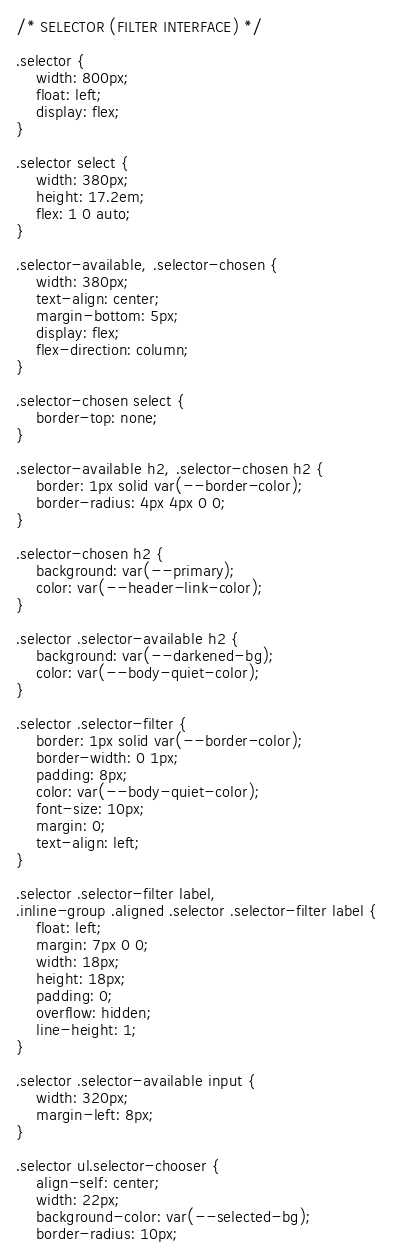Convert code to text. <code><loc_0><loc_0><loc_500><loc_500><_CSS_>/* SELECTOR (FILTER INTERFACE) */

.selector {
    width: 800px;
    float: left;
    display: flex;
}

.selector select {
    width: 380px;
    height: 17.2em;
    flex: 1 0 auto;
}

.selector-available, .selector-chosen {
    width: 380px;
    text-align: center;
    margin-bottom: 5px;
    display: flex;
    flex-direction: column;
}

.selector-chosen select {
    border-top: none;
}

.selector-available h2, .selector-chosen h2 {
    border: 1px solid var(--border-color);
    border-radius: 4px 4px 0 0;
}

.selector-chosen h2 {
    background: var(--primary);
    color: var(--header-link-color);
}

.selector .selector-available h2 {
    background: var(--darkened-bg);
    color: var(--body-quiet-color);
}

.selector .selector-filter {
    border: 1px solid var(--border-color);
    border-width: 0 1px;
    padding: 8px;
    color: var(--body-quiet-color);
    font-size: 10px;
    margin: 0;
    text-align: left;
}

.selector .selector-filter label,
.inline-group .aligned .selector .selector-filter label {
    float: left;
    margin: 7px 0 0;
    width: 18px;
    height: 18px;
    padding: 0;
    overflow: hidden;
    line-height: 1;
}

.selector .selector-available input {
    width: 320px;
    margin-left: 8px;
}

.selector ul.selector-chooser {
    align-self: center;
    width: 22px;
    background-color: var(--selected-bg);
    border-radius: 10px;</code> 